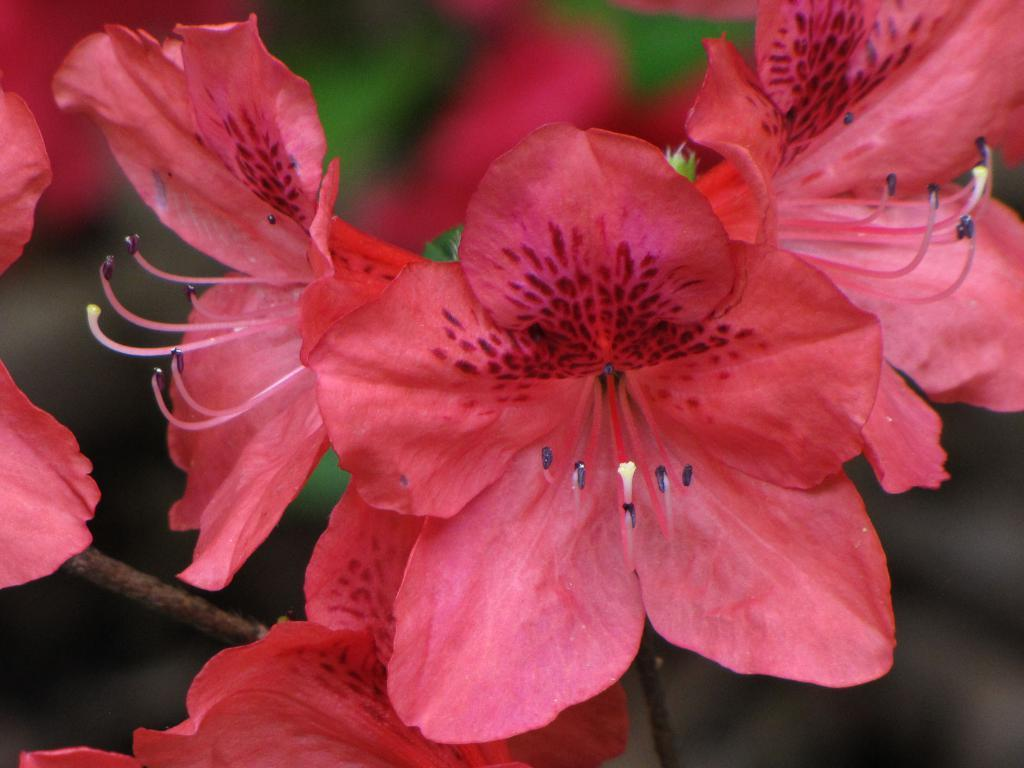What type of flowers are in the image? There are red color flowers in the image. What part of the flowers connects them to the ground or a vase? The flowers have stems. Can you describe the background of the image? The background of the image is blurred. What hobbies do the flowers enjoy during their recess time in the image? There are no hobbies or recess time for the flowers in the image, as they are inanimate objects. 